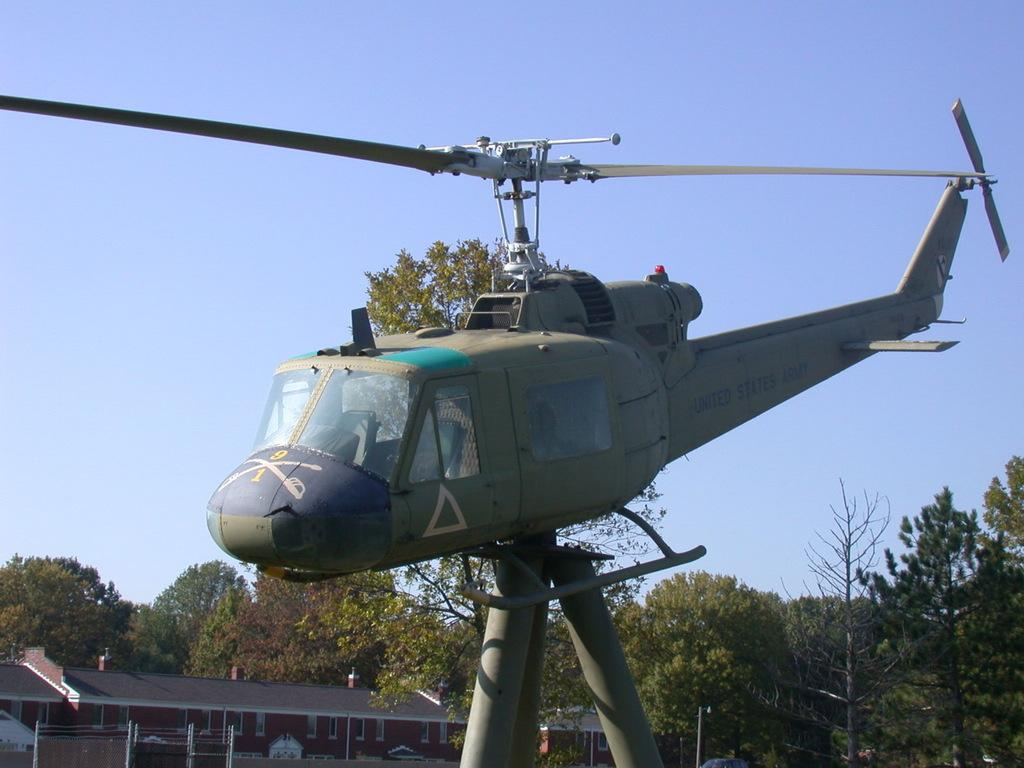What is the main subject of the image? The main subject of the image is a helicopter. How is the helicopter positioned in the image? The helicopter is on poles in the image. What can be seen in the background of the image? There is a building and trees in the background of the image. What type of verse can be heard recited by the glass coach in the image? There is no glass coach or verse present in the image; it features a helicopter on poles with a background of a building and trees. 